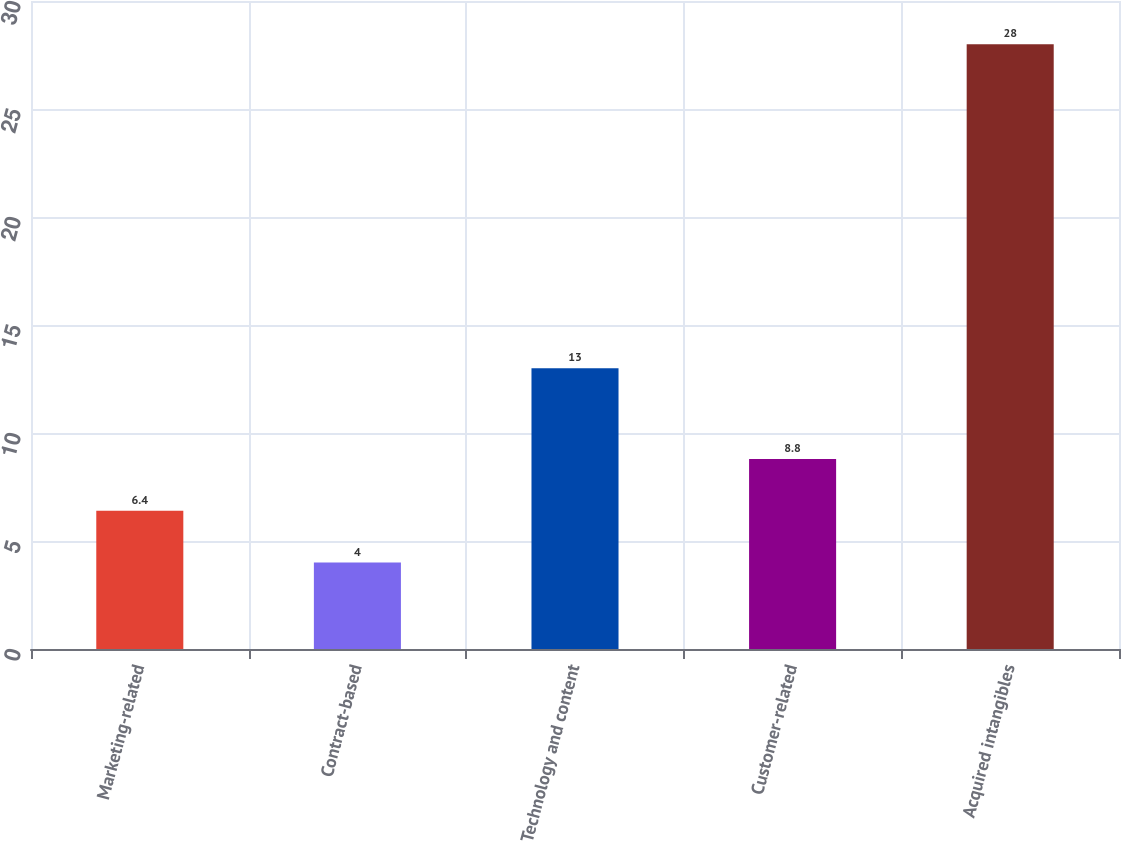Convert chart. <chart><loc_0><loc_0><loc_500><loc_500><bar_chart><fcel>Marketing-related<fcel>Contract-based<fcel>Technology and content<fcel>Customer-related<fcel>Acquired intangibles<nl><fcel>6.4<fcel>4<fcel>13<fcel>8.8<fcel>28<nl></chart> 